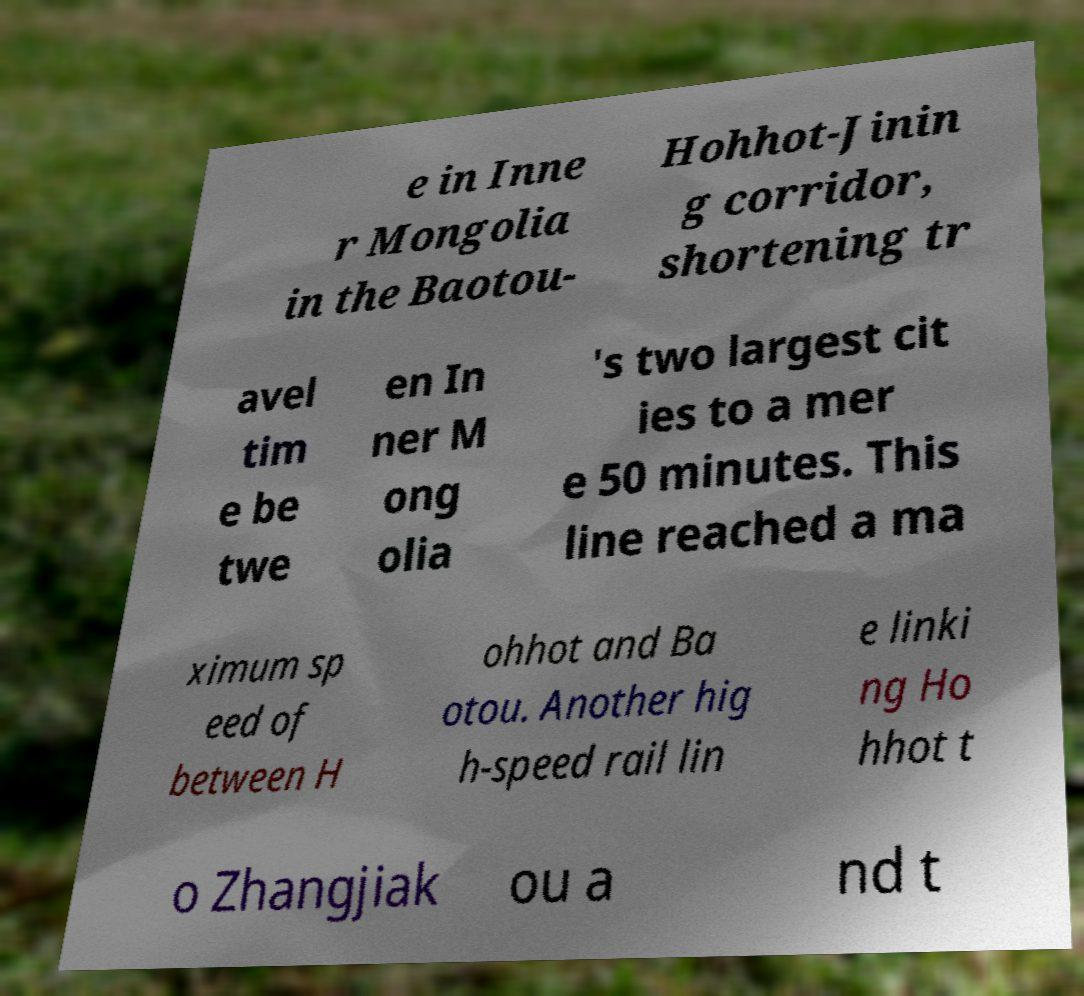Could you extract and type out the text from this image? e in Inne r Mongolia in the Baotou- Hohhot-Jinin g corridor, shortening tr avel tim e be twe en In ner M ong olia 's two largest cit ies to a mer e 50 minutes. This line reached a ma ximum sp eed of between H ohhot and Ba otou. Another hig h-speed rail lin e linki ng Ho hhot t o Zhangjiak ou a nd t 